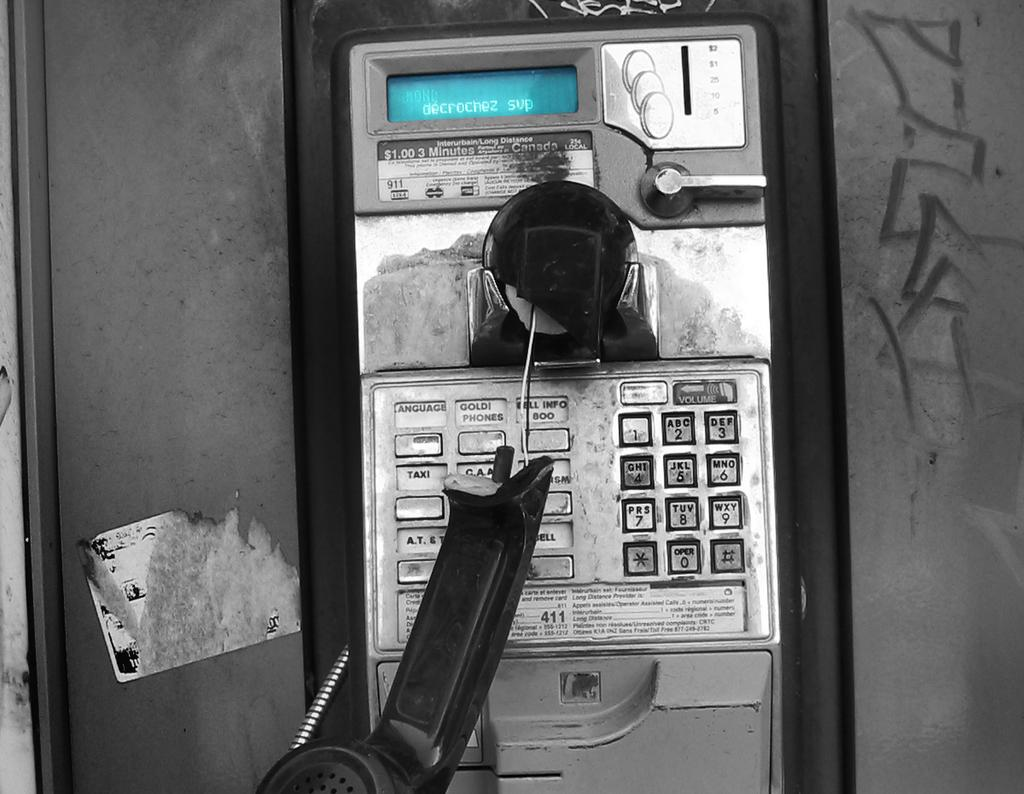<image>
Give a short and clear explanation of the subsequent image. A broken payphone says decrochez svp on the screen. 